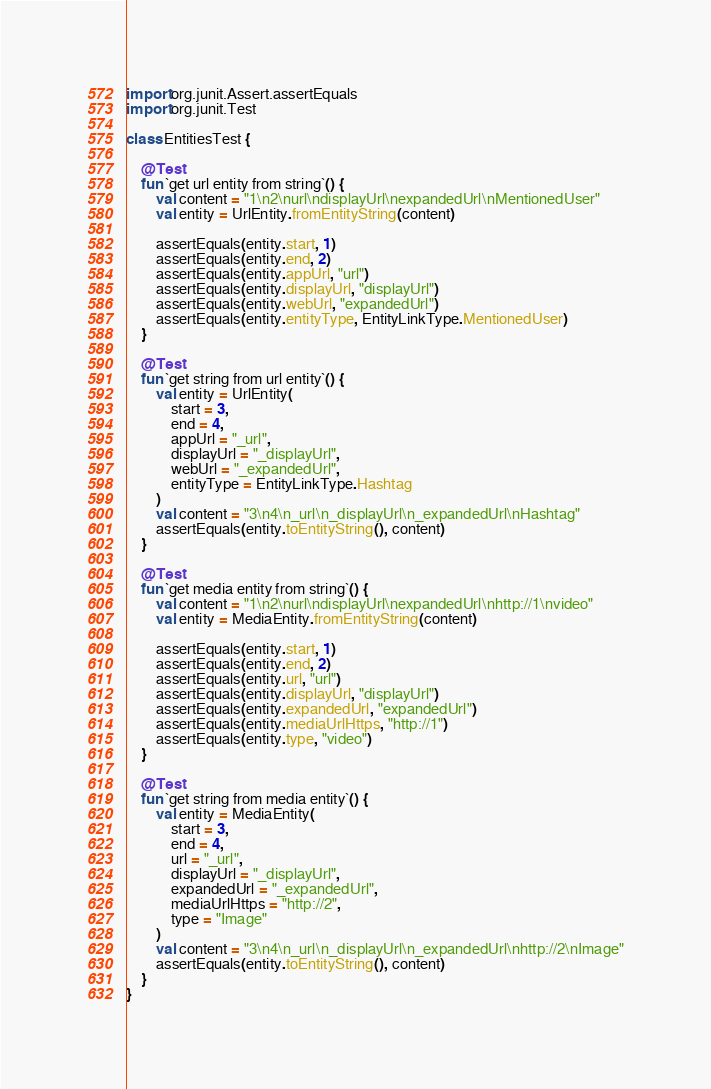Convert code to text. <code><loc_0><loc_0><loc_500><loc_500><_Kotlin_>import org.junit.Assert.assertEquals
import org.junit.Test

class EntitiesTest {

    @Test
    fun `get url entity from string`() {
        val content = "1\n2\nurl\ndisplayUrl\nexpandedUrl\nMentionedUser"
        val entity = UrlEntity.fromEntityString(content)

        assertEquals(entity.start, 1)
        assertEquals(entity.end, 2)
        assertEquals(entity.appUrl, "url")
        assertEquals(entity.displayUrl, "displayUrl")
        assertEquals(entity.webUrl, "expandedUrl")
        assertEquals(entity.entityType, EntityLinkType.MentionedUser)
    }

    @Test
    fun `get string from url entity`() {
        val entity = UrlEntity(
            start = 3,
            end = 4,
            appUrl = "_url",
            displayUrl = "_displayUrl",
            webUrl = "_expandedUrl",
            entityType = EntityLinkType.Hashtag
        )
        val content = "3\n4\n_url\n_displayUrl\n_expandedUrl\nHashtag"
        assertEquals(entity.toEntityString(), content)
    }

    @Test
    fun `get media entity from string`() {
        val content = "1\n2\nurl\ndisplayUrl\nexpandedUrl\nhttp://1\nvideo"
        val entity = MediaEntity.fromEntityString(content)

        assertEquals(entity.start, 1)
        assertEquals(entity.end, 2)
        assertEquals(entity.url, "url")
        assertEquals(entity.displayUrl, "displayUrl")
        assertEquals(entity.expandedUrl, "expandedUrl")
        assertEquals(entity.mediaUrlHttps, "http://1")
        assertEquals(entity.type, "video")
    }

    @Test
    fun `get string from media entity`() {
        val entity = MediaEntity(
            start = 3,
            end = 4,
            url = "_url",
            displayUrl = "_displayUrl",
            expandedUrl = "_expandedUrl",
            mediaUrlHttps = "http://2",
            type = "Image"
        )
        val content = "3\n4\n_url\n_displayUrl\n_expandedUrl\nhttp://2\nImage"
        assertEquals(entity.toEntityString(), content)
    }
}
</code> 